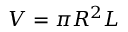<formula> <loc_0><loc_0><loc_500><loc_500>V = \pi R ^ { 2 } L</formula> 